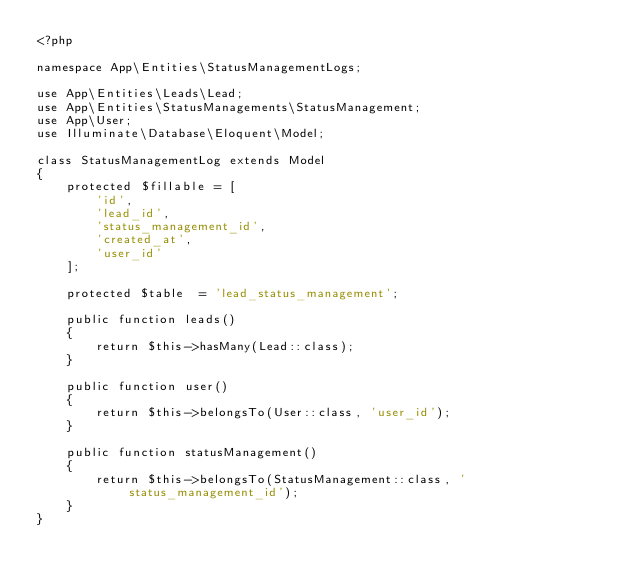<code> <loc_0><loc_0><loc_500><loc_500><_PHP_><?php

namespace App\Entities\StatusManagementLogs;

use App\Entities\Leads\Lead;
use App\Entities\StatusManagements\StatusManagement;
use App\User;
use Illuminate\Database\Eloquent\Model;

class StatusManagementLog extends Model
{
    protected $fillable = [
        'id',
        'lead_id',
        'status_management_id',
        'created_at',
        'user_id'
    ];

    protected $table  = 'lead_status_management';

    public function leads()
    {
        return $this->hasMany(Lead::class);
    }

    public function user()
    {
        return $this->belongsTo(User::class, 'user_id');
    }

    public function statusManagement()
    {
        return $this->belongsTo(StatusManagement::class, 'status_management_id');
    }
}
</code> 